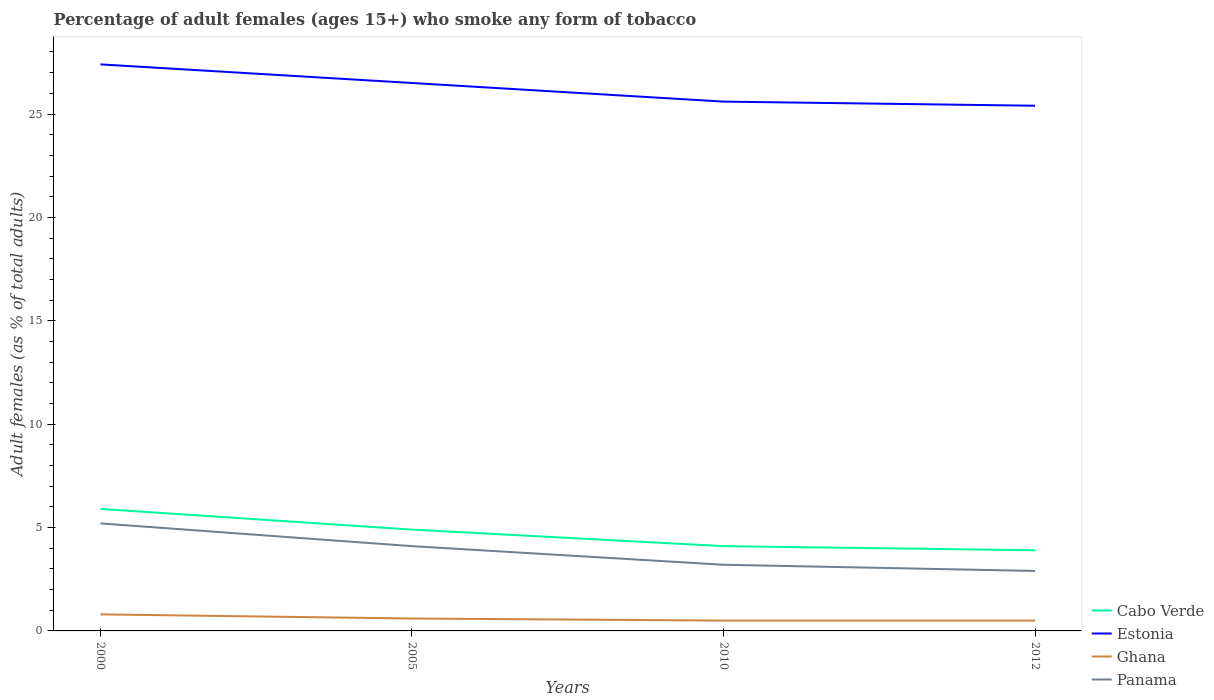How many different coloured lines are there?
Your answer should be very brief. 4. Across all years, what is the maximum percentage of adult females who smoke in Panama?
Provide a succinct answer. 2.9. In which year was the percentage of adult females who smoke in Cabo Verde maximum?
Your answer should be very brief. 2012. What is the total percentage of adult females who smoke in Panama in the graph?
Provide a short and direct response. 0.3. What is the difference between the highest and the second highest percentage of adult females who smoke in Cabo Verde?
Your answer should be compact. 2. How many years are there in the graph?
Provide a short and direct response. 4. What is the difference between two consecutive major ticks on the Y-axis?
Your response must be concise. 5. Does the graph contain grids?
Keep it short and to the point. No. Where does the legend appear in the graph?
Provide a succinct answer. Bottom right. How many legend labels are there?
Offer a terse response. 4. How are the legend labels stacked?
Your answer should be compact. Vertical. What is the title of the graph?
Give a very brief answer. Percentage of adult females (ages 15+) who smoke any form of tobacco. What is the label or title of the X-axis?
Give a very brief answer. Years. What is the label or title of the Y-axis?
Offer a terse response. Adult females (as % of total adults). What is the Adult females (as % of total adults) of Cabo Verde in 2000?
Give a very brief answer. 5.9. What is the Adult females (as % of total adults) in Estonia in 2000?
Provide a short and direct response. 27.4. What is the Adult females (as % of total adults) in Ghana in 2000?
Keep it short and to the point. 0.8. What is the Adult females (as % of total adults) in Panama in 2005?
Ensure brevity in your answer.  4.1. What is the Adult females (as % of total adults) in Estonia in 2010?
Your answer should be very brief. 25.6. What is the Adult females (as % of total adults) of Estonia in 2012?
Provide a succinct answer. 25.4. Across all years, what is the maximum Adult females (as % of total adults) of Estonia?
Offer a very short reply. 27.4. Across all years, what is the maximum Adult females (as % of total adults) of Ghana?
Make the answer very short. 0.8. Across all years, what is the maximum Adult females (as % of total adults) in Panama?
Your answer should be very brief. 5.2. Across all years, what is the minimum Adult females (as % of total adults) of Cabo Verde?
Give a very brief answer. 3.9. Across all years, what is the minimum Adult females (as % of total adults) in Estonia?
Ensure brevity in your answer.  25.4. Across all years, what is the minimum Adult females (as % of total adults) of Ghana?
Keep it short and to the point. 0.5. Across all years, what is the minimum Adult females (as % of total adults) of Panama?
Make the answer very short. 2.9. What is the total Adult females (as % of total adults) in Estonia in the graph?
Give a very brief answer. 104.9. What is the total Adult females (as % of total adults) in Panama in the graph?
Ensure brevity in your answer.  15.4. What is the difference between the Adult females (as % of total adults) of Cabo Verde in 2000 and that in 2005?
Your answer should be compact. 1. What is the difference between the Adult females (as % of total adults) of Estonia in 2000 and that in 2005?
Keep it short and to the point. 0.9. What is the difference between the Adult females (as % of total adults) of Panama in 2000 and that in 2005?
Provide a short and direct response. 1.1. What is the difference between the Adult females (as % of total adults) in Cabo Verde in 2005 and that in 2010?
Keep it short and to the point. 0.8. What is the difference between the Adult females (as % of total adults) in Ghana in 2005 and that in 2010?
Your answer should be very brief. 0.1. What is the difference between the Adult females (as % of total adults) in Cabo Verde in 2005 and that in 2012?
Provide a short and direct response. 1. What is the difference between the Adult females (as % of total adults) of Estonia in 2005 and that in 2012?
Offer a terse response. 1.1. What is the difference between the Adult females (as % of total adults) in Ghana in 2010 and that in 2012?
Keep it short and to the point. 0. What is the difference between the Adult females (as % of total adults) of Cabo Verde in 2000 and the Adult females (as % of total adults) of Estonia in 2005?
Make the answer very short. -20.6. What is the difference between the Adult females (as % of total adults) of Cabo Verde in 2000 and the Adult females (as % of total adults) of Panama in 2005?
Your answer should be very brief. 1.8. What is the difference between the Adult females (as % of total adults) in Estonia in 2000 and the Adult females (as % of total adults) in Ghana in 2005?
Your response must be concise. 26.8. What is the difference between the Adult females (as % of total adults) in Estonia in 2000 and the Adult females (as % of total adults) in Panama in 2005?
Keep it short and to the point. 23.3. What is the difference between the Adult females (as % of total adults) in Cabo Verde in 2000 and the Adult females (as % of total adults) in Estonia in 2010?
Make the answer very short. -19.7. What is the difference between the Adult females (as % of total adults) in Cabo Verde in 2000 and the Adult females (as % of total adults) in Ghana in 2010?
Provide a succinct answer. 5.4. What is the difference between the Adult females (as % of total adults) of Cabo Verde in 2000 and the Adult females (as % of total adults) of Panama in 2010?
Offer a terse response. 2.7. What is the difference between the Adult females (as % of total adults) of Estonia in 2000 and the Adult females (as % of total adults) of Ghana in 2010?
Provide a short and direct response. 26.9. What is the difference between the Adult females (as % of total adults) in Estonia in 2000 and the Adult females (as % of total adults) in Panama in 2010?
Provide a short and direct response. 24.2. What is the difference between the Adult females (as % of total adults) in Ghana in 2000 and the Adult females (as % of total adults) in Panama in 2010?
Give a very brief answer. -2.4. What is the difference between the Adult females (as % of total adults) in Cabo Verde in 2000 and the Adult females (as % of total adults) in Estonia in 2012?
Offer a very short reply. -19.5. What is the difference between the Adult females (as % of total adults) of Cabo Verde in 2000 and the Adult females (as % of total adults) of Panama in 2012?
Keep it short and to the point. 3. What is the difference between the Adult females (as % of total adults) in Estonia in 2000 and the Adult females (as % of total adults) in Ghana in 2012?
Provide a succinct answer. 26.9. What is the difference between the Adult females (as % of total adults) of Cabo Verde in 2005 and the Adult females (as % of total adults) of Estonia in 2010?
Provide a short and direct response. -20.7. What is the difference between the Adult females (as % of total adults) of Cabo Verde in 2005 and the Adult females (as % of total adults) of Panama in 2010?
Your response must be concise. 1.7. What is the difference between the Adult females (as % of total adults) of Estonia in 2005 and the Adult females (as % of total adults) of Panama in 2010?
Offer a very short reply. 23.3. What is the difference between the Adult females (as % of total adults) of Ghana in 2005 and the Adult females (as % of total adults) of Panama in 2010?
Offer a terse response. -2.6. What is the difference between the Adult females (as % of total adults) of Cabo Verde in 2005 and the Adult females (as % of total adults) of Estonia in 2012?
Your answer should be compact. -20.5. What is the difference between the Adult females (as % of total adults) of Cabo Verde in 2005 and the Adult females (as % of total adults) of Ghana in 2012?
Keep it short and to the point. 4.4. What is the difference between the Adult females (as % of total adults) in Cabo Verde in 2005 and the Adult females (as % of total adults) in Panama in 2012?
Offer a very short reply. 2. What is the difference between the Adult females (as % of total adults) in Estonia in 2005 and the Adult females (as % of total adults) in Ghana in 2012?
Offer a very short reply. 26. What is the difference between the Adult females (as % of total adults) of Estonia in 2005 and the Adult females (as % of total adults) of Panama in 2012?
Keep it short and to the point. 23.6. What is the difference between the Adult females (as % of total adults) of Cabo Verde in 2010 and the Adult females (as % of total adults) of Estonia in 2012?
Offer a very short reply. -21.3. What is the difference between the Adult females (as % of total adults) in Cabo Verde in 2010 and the Adult females (as % of total adults) in Ghana in 2012?
Keep it short and to the point. 3.6. What is the difference between the Adult females (as % of total adults) of Estonia in 2010 and the Adult females (as % of total adults) of Ghana in 2012?
Offer a terse response. 25.1. What is the difference between the Adult females (as % of total adults) of Estonia in 2010 and the Adult females (as % of total adults) of Panama in 2012?
Provide a short and direct response. 22.7. What is the difference between the Adult females (as % of total adults) in Ghana in 2010 and the Adult females (as % of total adults) in Panama in 2012?
Your response must be concise. -2.4. What is the average Adult females (as % of total adults) of Cabo Verde per year?
Ensure brevity in your answer.  4.7. What is the average Adult females (as % of total adults) in Estonia per year?
Make the answer very short. 26.23. What is the average Adult females (as % of total adults) of Ghana per year?
Your response must be concise. 0.6. What is the average Adult females (as % of total adults) in Panama per year?
Keep it short and to the point. 3.85. In the year 2000, what is the difference between the Adult females (as % of total adults) in Cabo Verde and Adult females (as % of total adults) in Estonia?
Ensure brevity in your answer.  -21.5. In the year 2000, what is the difference between the Adult females (as % of total adults) of Cabo Verde and Adult females (as % of total adults) of Ghana?
Provide a succinct answer. 5.1. In the year 2000, what is the difference between the Adult females (as % of total adults) in Estonia and Adult females (as % of total adults) in Ghana?
Your answer should be compact. 26.6. In the year 2000, what is the difference between the Adult females (as % of total adults) in Ghana and Adult females (as % of total adults) in Panama?
Your answer should be compact. -4.4. In the year 2005, what is the difference between the Adult females (as % of total adults) of Cabo Verde and Adult females (as % of total adults) of Estonia?
Provide a short and direct response. -21.6. In the year 2005, what is the difference between the Adult females (as % of total adults) in Estonia and Adult females (as % of total adults) in Ghana?
Keep it short and to the point. 25.9. In the year 2005, what is the difference between the Adult females (as % of total adults) of Estonia and Adult females (as % of total adults) of Panama?
Make the answer very short. 22.4. In the year 2005, what is the difference between the Adult females (as % of total adults) in Ghana and Adult females (as % of total adults) in Panama?
Provide a succinct answer. -3.5. In the year 2010, what is the difference between the Adult females (as % of total adults) in Cabo Verde and Adult females (as % of total adults) in Estonia?
Offer a terse response. -21.5. In the year 2010, what is the difference between the Adult females (as % of total adults) in Cabo Verde and Adult females (as % of total adults) in Panama?
Your response must be concise. 0.9. In the year 2010, what is the difference between the Adult females (as % of total adults) in Estonia and Adult females (as % of total adults) in Ghana?
Your answer should be compact. 25.1. In the year 2010, what is the difference between the Adult females (as % of total adults) of Estonia and Adult females (as % of total adults) of Panama?
Your answer should be compact. 22.4. In the year 2010, what is the difference between the Adult females (as % of total adults) in Ghana and Adult females (as % of total adults) in Panama?
Offer a very short reply. -2.7. In the year 2012, what is the difference between the Adult females (as % of total adults) in Cabo Verde and Adult females (as % of total adults) in Estonia?
Your answer should be very brief. -21.5. In the year 2012, what is the difference between the Adult females (as % of total adults) in Cabo Verde and Adult females (as % of total adults) in Panama?
Your answer should be compact. 1. In the year 2012, what is the difference between the Adult females (as % of total adults) of Estonia and Adult females (as % of total adults) of Ghana?
Your answer should be very brief. 24.9. In the year 2012, what is the difference between the Adult females (as % of total adults) of Ghana and Adult females (as % of total adults) of Panama?
Your answer should be very brief. -2.4. What is the ratio of the Adult females (as % of total adults) of Cabo Verde in 2000 to that in 2005?
Your answer should be compact. 1.2. What is the ratio of the Adult females (as % of total adults) of Estonia in 2000 to that in 2005?
Make the answer very short. 1.03. What is the ratio of the Adult females (as % of total adults) in Panama in 2000 to that in 2005?
Offer a terse response. 1.27. What is the ratio of the Adult females (as % of total adults) in Cabo Verde in 2000 to that in 2010?
Your response must be concise. 1.44. What is the ratio of the Adult females (as % of total adults) in Estonia in 2000 to that in 2010?
Your answer should be very brief. 1.07. What is the ratio of the Adult females (as % of total adults) of Panama in 2000 to that in 2010?
Offer a terse response. 1.62. What is the ratio of the Adult females (as % of total adults) of Cabo Verde in 2000 to that in 2012?
Offer a very short reply. 1.51. What is the ratio of the Adult females (as % of total adults) in Estonia in 2000 to that in 2012?
Your response must be concise. 1.08. What is the ratio of the Adult females (as % of total adults) in Panama in 2000 to that in 2012?
Offer a terse response. 1.79. What is the ratio of the Adult females (as % of total adults) of Cabo Verde in 2005 to that in 2010?
Make the answer very short. 1.2. What is the ratio of the Adult females (as % of total adults) of Estonia in 2005 to that in 2010?
Offer a very short reply. 1.04. What is the ratio of the Adult females (as % of total adults) in Panama in 2005 to that in 2010?
Offer a very short reply. 1.28. What is the ratio of the Adult females (as % of total adults) of Cabo Verde in 2005 to that in 2012?
Offer a very short reply. 1.26. What is the ratio of the Adult females (as % of total adults) in Estonia in 2005 to that in 2012?
Keep it short and to the point. 1.04. What is the ratio of the Adult females (as % of total adults) in Panama in 2005 to that in 2012?
Provide a short and direct response. 1.41. What is the ratio of the Adult females (as % of total adults) of Cabo Verde in 2010 to that in 2012?
Provide a short and direct response. 1.05. What is the ratio of the Adult females (as % of total adults) in Estonia in 2010 to that in 2012?
Give a very brief answer. 1.01. What is the ratio of the Adult females (as % of total adults) in Panama in 2010 to that in 2012?
Your answer should be compact. 1.1. What is the difference between the highest and the second highest Adult females (as % of total adults) in Estonia?
Ensure brevity in your answer.  0.9. What is the difference between the highest and the lowest Adult females (as % of total adults) of Cabo Verde?
Offer a very short reply. 2. What is the difference between the highest and the lowest Adult females (as % of total adults) of Panama?
Offer a terse response. 2.3. 